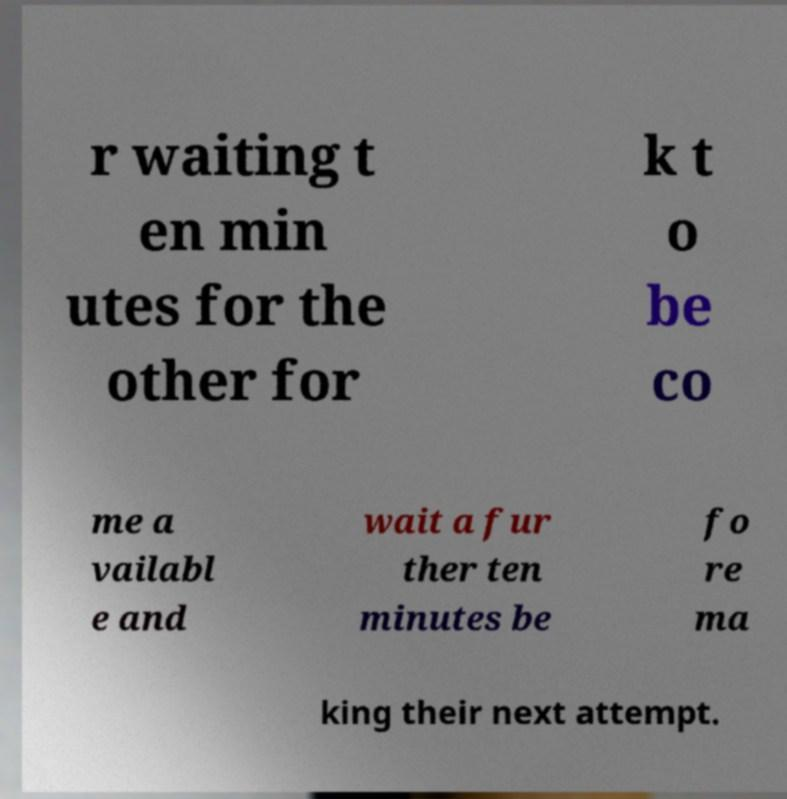Could you extract and type out the text from this image? r waiting t en min utes for the other for k t o be co me a vailabl e and wait a fur ther ten minutes be fo re ma king their next attempt. 